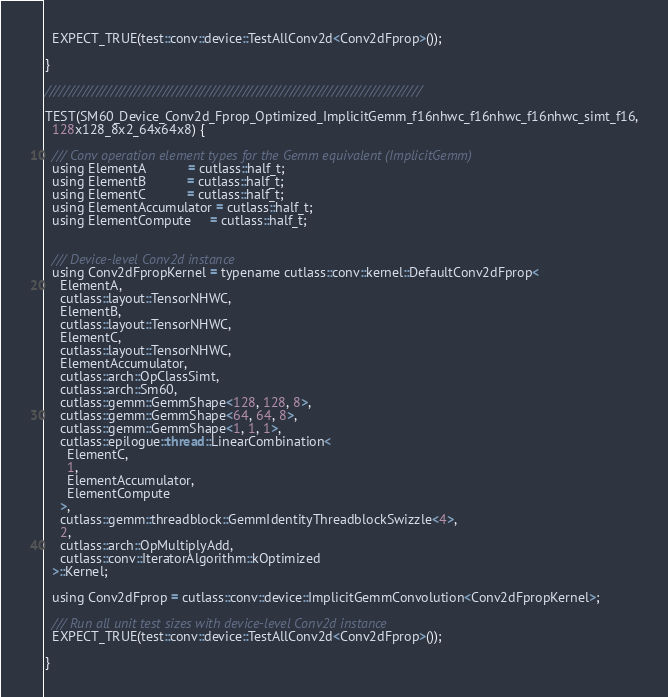<code> <loc_0><loc_0><loc_500><loc_500><_Cuda_>  EXPECT_TRUE(test::conv::device::TestAllConv2d<Conv2dFprop>());

}

////////////////////////////////////////////////////////////////////////////////

TEST(SM60_Device_Conv2d_Fprop_Optimized_ImplicitGemm_f16nhwc_f16nhwc_f16nhwc_simt_f16,
  128x128_8x2_64x64x8) {

  /// Conv operation element types for the Gemm equivalent (ImplicitGemm)
  using ElementA           = cutlass::half_t;
  using ElementB           = cutlass::half_t;
  using ElementC           = cutlass::half_t;
  using ElementAccumulator = cutlass::half_t;
  using ElementCompute     = cutlass::half_t;


  /// Device-level Conv2d instance
  using Conv2dFpropKernel = typename cutlass::conv::kernel::DefaultConv2dFprop<
    ElementA, 
    cutlass::layout::TensorNHWC,
    ElementB, 
    cutlass::layout::TensorNHWC,
    ElementC, 
    cutlass::layout::TensorNHWC,
    ElementAccumulator,
    cutlass::arch::OpClassSimt,
    cutlass::arch::Sm60,
    cutlass::gemm::GemmShape<128, 128, 8>,
    cutlass::gemm::GemmShape<64, 64, 8>, 
    cutlass::gemm::GemmShape<1, 1, 1>,
    cutlass::epilogue::thread::LinearCombination<
      ElementC,
      1,
      ElementAccumulator,
      ElementCompute
    >,
    cutlass::gemm::threadblock::GemmIdentityThreadblockSwizzle<4>,
    2,
    cutlass::arch::OpMultiplyAdd,
    cutlass::conv::IteratorAlgorithm::kOptimized
  >::Kernel;

  using Conv2dFprop = cutlass::conv::device::ImplicitGemmConvolution<Conv2dFpropKernel>;

  /// Run all unit test sizes with device-level Conv2d instance
  EXPECT_TRUE(test::conv::device::TestAllConv2d<Conv2dFprop>());

}
</code> 